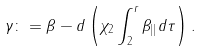<formula> <loc_0><loc_0><loc_500><loc_500>\gamma \colon = \beta - d \left ( \chi _ { 2 } \int _ { 2 } ^ { r } \beta _ { | | } d \tau \right ) .</formula> 